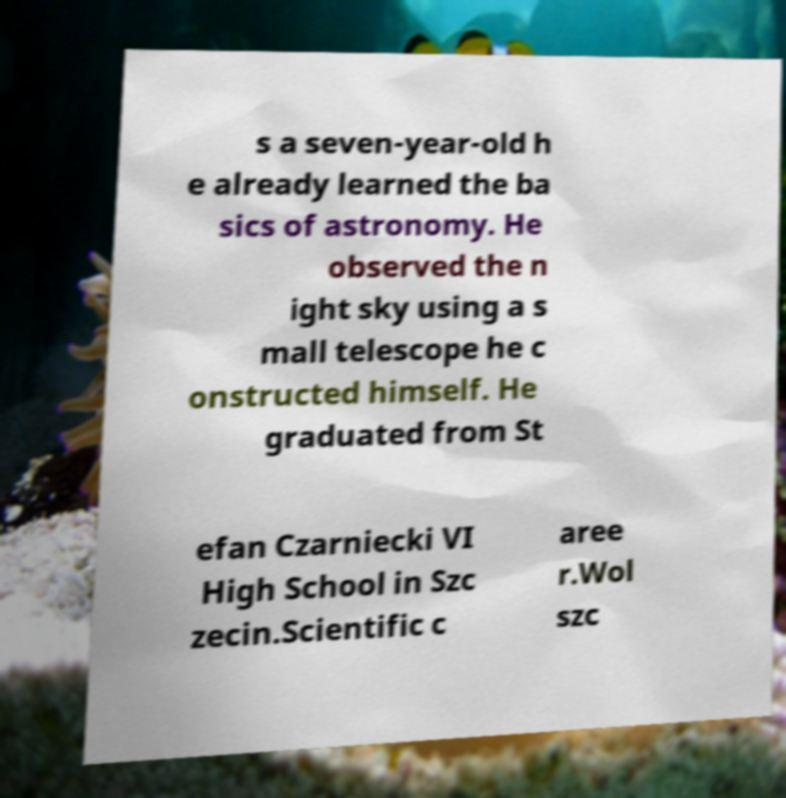What messages or text are displayed in this image? I need them in a readable, typed format. s a seven-year-old h e already learned the ba sics of astronomy. He observed the n ight sky using a s mall telescope he c onstructed himself. He graduated from St efan Czarniecki VI High School in Szc zecin.Scientific c aree r.Wol szc 